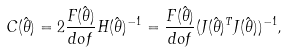<formula> <loc_0><loc_0><loc_500><loc_500>C ( \hat { \theta } ) = 2 \frac { F ( \hat { \theta } ) } { d o f } H ( \hat { \theta } ) ^ { - 1 } = \frac { F ( \hat { \theta } ) } { d o f } ( J ( \hat { \theta } ) ^ { T } J ( \hat { \theta } ) ) ^ { - 1 } ,</formula> 